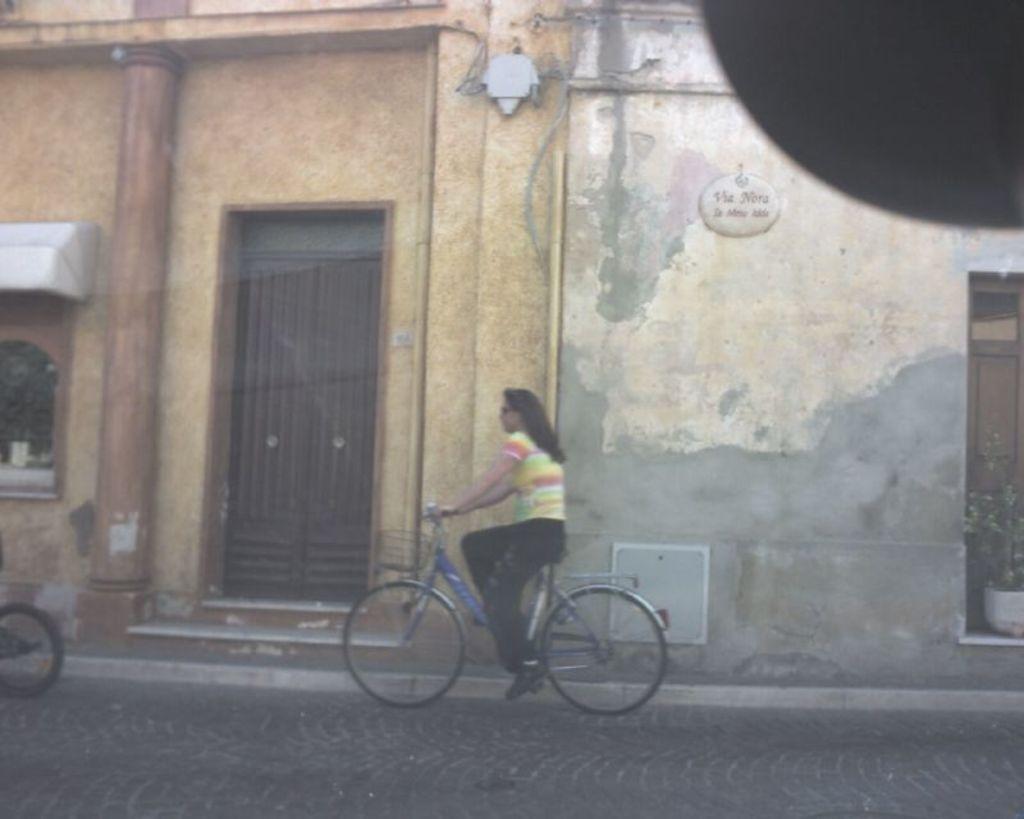In one or two sentences, can you explain what this image depicts? In this picture I can see in the middle a woman is riding a bicycle, in the background it looks like a building. On the right side there is a plant. 